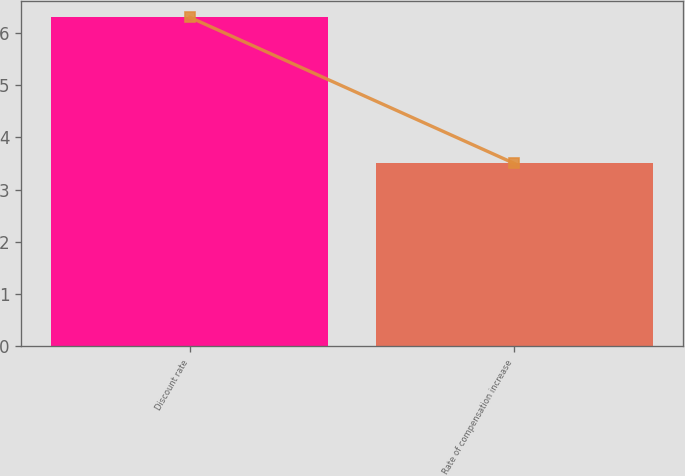Convert chart. <chart><loc_0><loc_0><loc_500><loc_500><bar_chart><fcel>Discount rate<fcel>Rate of compensation increase<nl><fcel>6.3<fcel>3.5<nl></chart> 